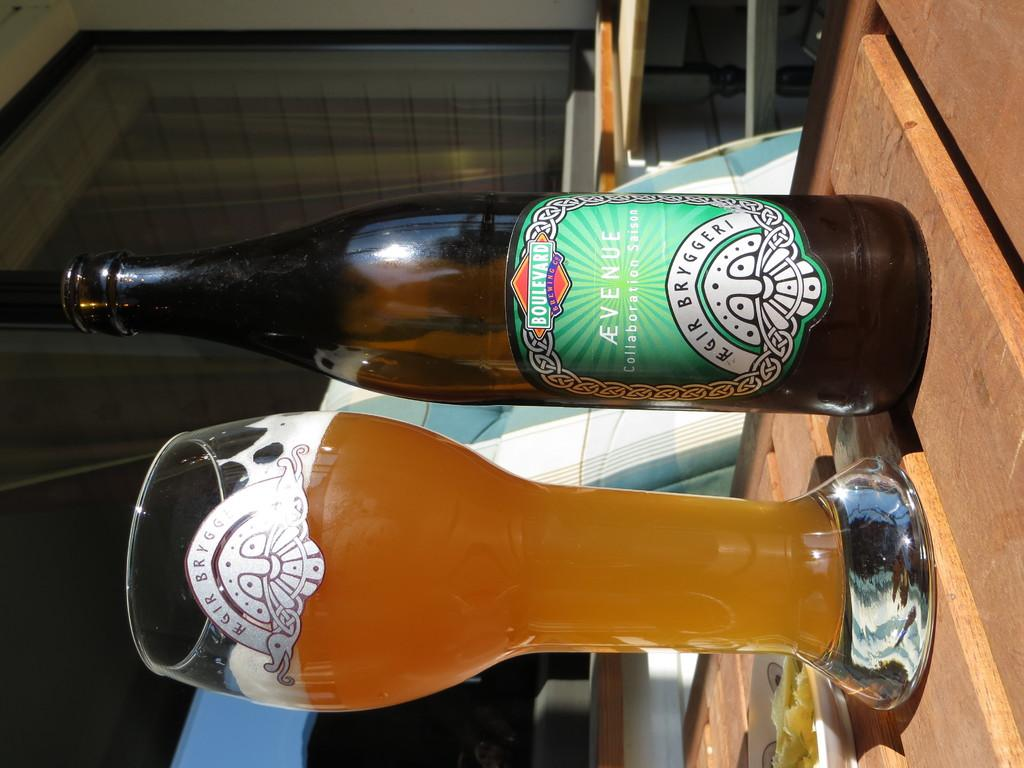<image>
Summarize the visual content of the image. A glass of Avenue beer next to its empty bottle. 